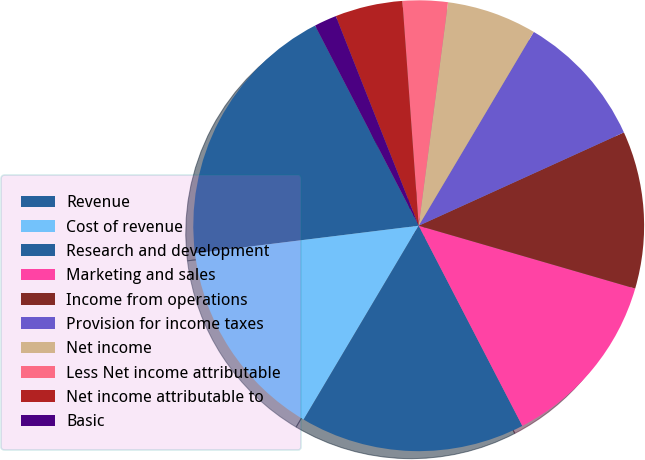Convert chart to OTSL. <chart><loc_0><loc_0><loc_500><loc_500><pie_chart><fcel>Revenue<fcel>Cost of revenue<fcel>Research and development<fcel>Marketing and sales<fcel>Income from operations<fcel>Provision for income taxes<fcel>Net income<fcel>Less Net income attributable<fcel>Net income attributable to<fcel>Basic<nl><fcel>19.35%<fcel>14.52%<fcel>16.13%<fcel>12.9%<fcel>11.29%<fcel>9.68%<fcel>6.45%<fcel>3.23%<fcel>4.84%<fcel>1.61%<nl></chart> 